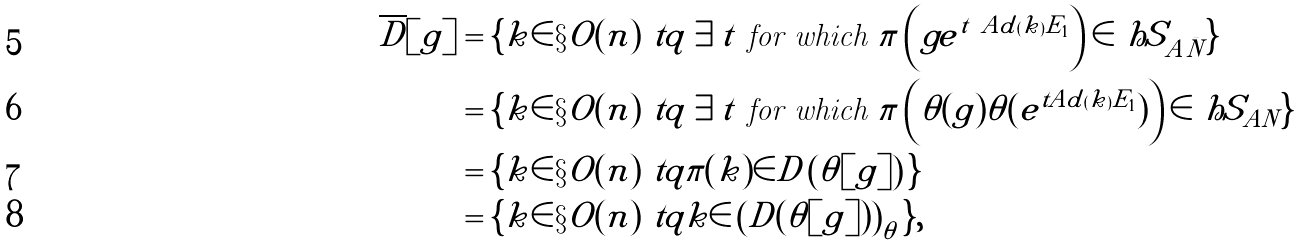Convert formula to latex. <formula><loc_0><loc_0><loc_500><loc_500>\overline { D } [ g ] & = \{ k \in \S O ( n ) \ t q \exists t \text { for which } \pi \left ( g e ^ { t \ A d ( k ) E _ { 1 } } \right ) \in \ h S _ { A \bar { N } } \} \\ & = \{ k \in \S O ( n ) \ t q \exists t \text { for which } \pi \left ( \theta ( g ) \theta ( e ^ { t A d ( k ) E _ { 1 } } ) \right ) \in \ h S _ { A N } \} \\ & = \{ k \in \S O ( n ) \ t q \pi ( k ) \in D \left ( \theta [ g ] \right ) \} \\ & = \{ k \in \S O ( n ) \ t q k \in \left ( D ( \theta [ g ] ) \right ) _ { \theta } \} ,</formula> 